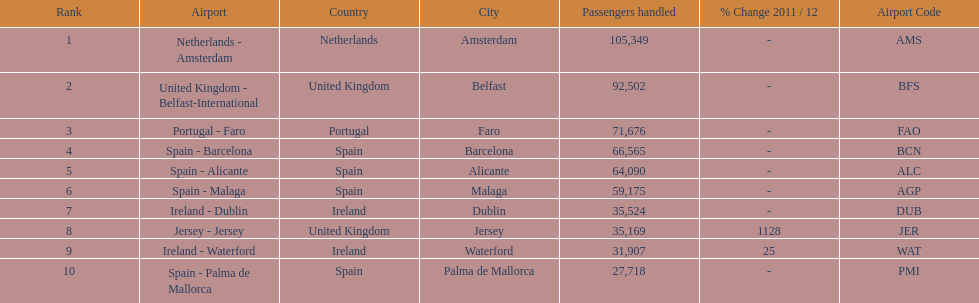What is the name of the only airport in portugal that is among the 10 busiest routes to and from london southend airport in 2012? Portugal - Faro. 